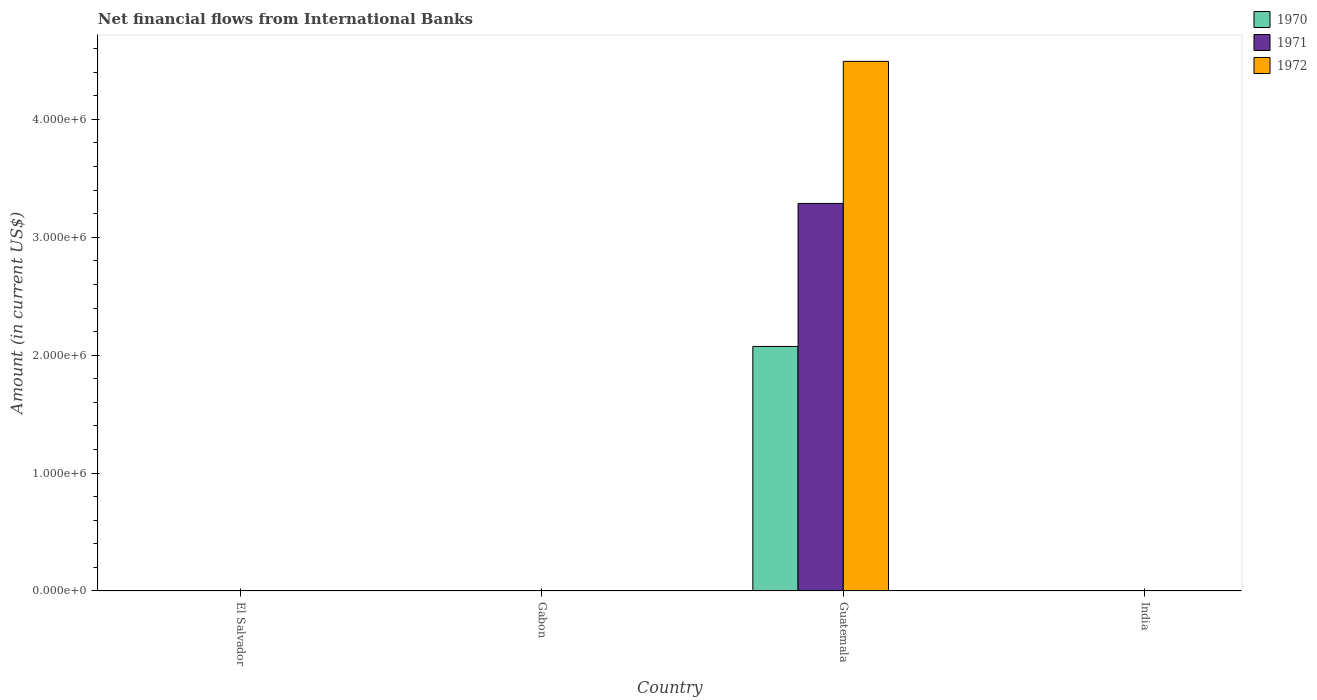How many different coloured bars are there?
Your answer should be very brief. 3. Are the number of bars per tick equal to the number of legend labels?
Make the answer very short. No. Are the number of bars on each tick of the X-axis equal?
Provide a short and direct response. No. How many bars are there on the 1st tick from the left?
Make the answer very short. 0. What is the label of the 1st group of bars from the left?
Your response must be concise. El Salvador. What is the net financial aid flows in 1971 in El Salvador?
Ensure brevity in your answer.  0. Across all countries, what is the maximum net financial aid flows in 1970?
Offer a very short reply. 2.07e+06. In which country was the net financial aid flows in 1971 maximum?
Keep it short and to the point. Guatemala. What is the total net financial aid flows in 1972 in the graph?
Give a very brief answer. 4.49e+06. What is the difference between the net financial aid flows in 1972 in Guatemala and the net financial aid flows in 1970 in India?
Provide a succinct answer. 4.49e+06. What is the average net financial aid flows in 1970 per country?
Give a very brief answer. 5.18e+05. What is the difference between the net financial aid flows of/in 1972 and net financial aid flows of/in 1971 in Guatemala?
Your answer should be very brief. 1.20e+06. What is the difference between the highest and the lowest net financial aid flows in 1970?
Provide a short and direct response. 2.07e+06. In how many countries, is the net financial aid flows in 1972 greater than the average net financial aid flows in 1972 taken over all countries?
Provide a succinct answer. 1. How many bars are there?
Keep it short and to the point. 3. What is the difference between two consecutive major ticks on the Y-axis?
Give a very brief answer. 1.00e+06. Are the values on the major ticks of Y-axis written in scientific E-notation?
Provide a succinct answer. Yes. Where does the legend appear in the graph?
Ensure brevity in your answer.  Top right. How many legend labels are there?
Give a very brief answer. 3. How are the legend labels stacked?
Your answer should be very brief. Vertical. What is the title of the graph?
Make the answer very short. Net financial flows from International Banks. What is the label or title of the X-axis?
Ensure brevity in your answer.  Country. What is the Amount (in current US$) in 1970 in El Salvador?
Your response must be concise. 0. What is the Amount (in current US$) of 1971 in El Salvador?
Your answer should be compact. 0. What is the Amount (in current US$) of 1972 in El Salvador?
Offer a very short reply. 0. What is the Amount (in current US$) of 1970 in Gabon?
Provide a short and direct response. 0. What is the Amount (in current US$) in 1970 in Guatemala?
Offer a terse response. 2.07e+06. What is the Amount (in current US$) in 1971 in Guatemala?
Offer a terse response. 3.29e+06. What is the Amount (in current US$) in 1972 in Guatemala?
Your response must be concise. 4.49e+06. What is the Amount (in current US$) of 1970 in India?
Provide a short and direct response. 0. What is the Amount (in current US$) of 1971 in India?
Keep it short and to the point. 0. Across all countries, what is the maximum Amount (in current US$) in 1970?
Provide a succinct answer. 2.07e+06. Across all countries, what is the maximum Amount (in current US$) of 1971?
Offer a very short reply. 3.29e+06. Across all countries, what is the maximum Amount (in current US$) of 1972?
Offer a very short reply. 4.49e+06. Across all countries, what is the minimum Amount (in current US$) of 1970?
Give a very brief answer. 0. Across all countries, what is the minimum Amount (in current US$) in 1971?
Ensure brevity in your answer.  0. Across all countries, what is the minimum Amount (in current US$) of 1972?
Your response must be concise. 0. What is the total Amount (in current US$) of 1970 in the graph?
Make the answer very short. 2.07e+06. What is the total Amount (in current US$) in 1971 in the graph?
Your answer should be very brief. 3.29e+06. What is the total Amount (in current US$) in 1972 in the graph?
Give a very brief answer. 4.49e+06. What is the average Amount (in current US$) in 1970 per country?
Your answer should be very brief. 5.18e+05. What is the average Amount (in current US$) in 1971 per country?
Make the answer very short. 8.22e+05. What is the average Amount (in current US$) of 1972 per country?
Your response must be concise. 1.12e+06. What is the difference between the Amount (in current US$) in 1970 and Amount (in current US$) in 1971 in Guatemala?
Provide a succinct answer. -1.21e+06. What is the difference between the Amount (in current US$) of 1970 and Amount (in current US$) of 1972 in Guatemala?
Make the answer very short. -2.42e+06. What is the difference between the Amount (in current US$) in 1971 and Amount (in current US$) in 1972 in Guatemala?
Offer a very short reply. -1.20e+06. What is the difference between the highest and the lowest Amount (in current US$) in 1970?
Keep it short and to the point. 2.07e+06. What is the difference between the highest and the lowest Amount (in current US$) in 1971?
Keep it short and to the point. 3.29e+06. What is the difference between the highest and the lowest Amount (in current US$) in 1972?
Offer a very short reply. 4.49e+06. 